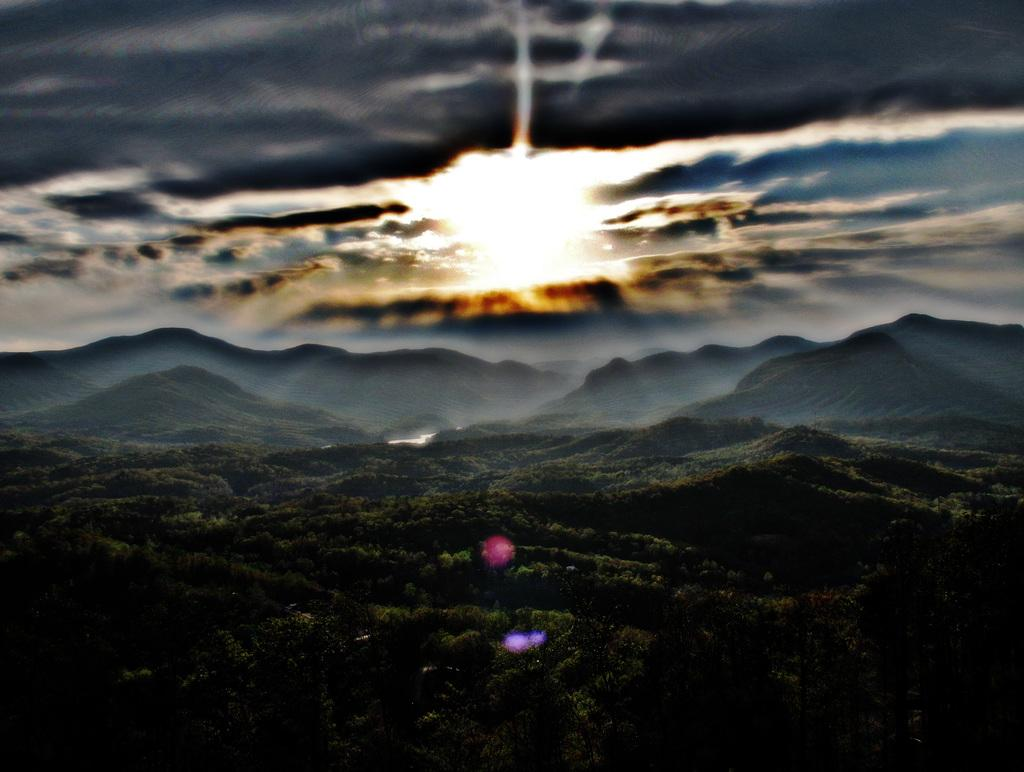What type of natural environment is depicted in the image? The image features many trees and hills, indicating a natural setting. Can you describe the sky in the image? The sky is cloudy in the image. Where is the boy sitting at the table in the image? There is no boy or table present in the image; it features trees, hills, and a cloudy sky. What type of music is the band playing in the image? There is no band present in the image; it features trees, hills, and a cloudy sky. 